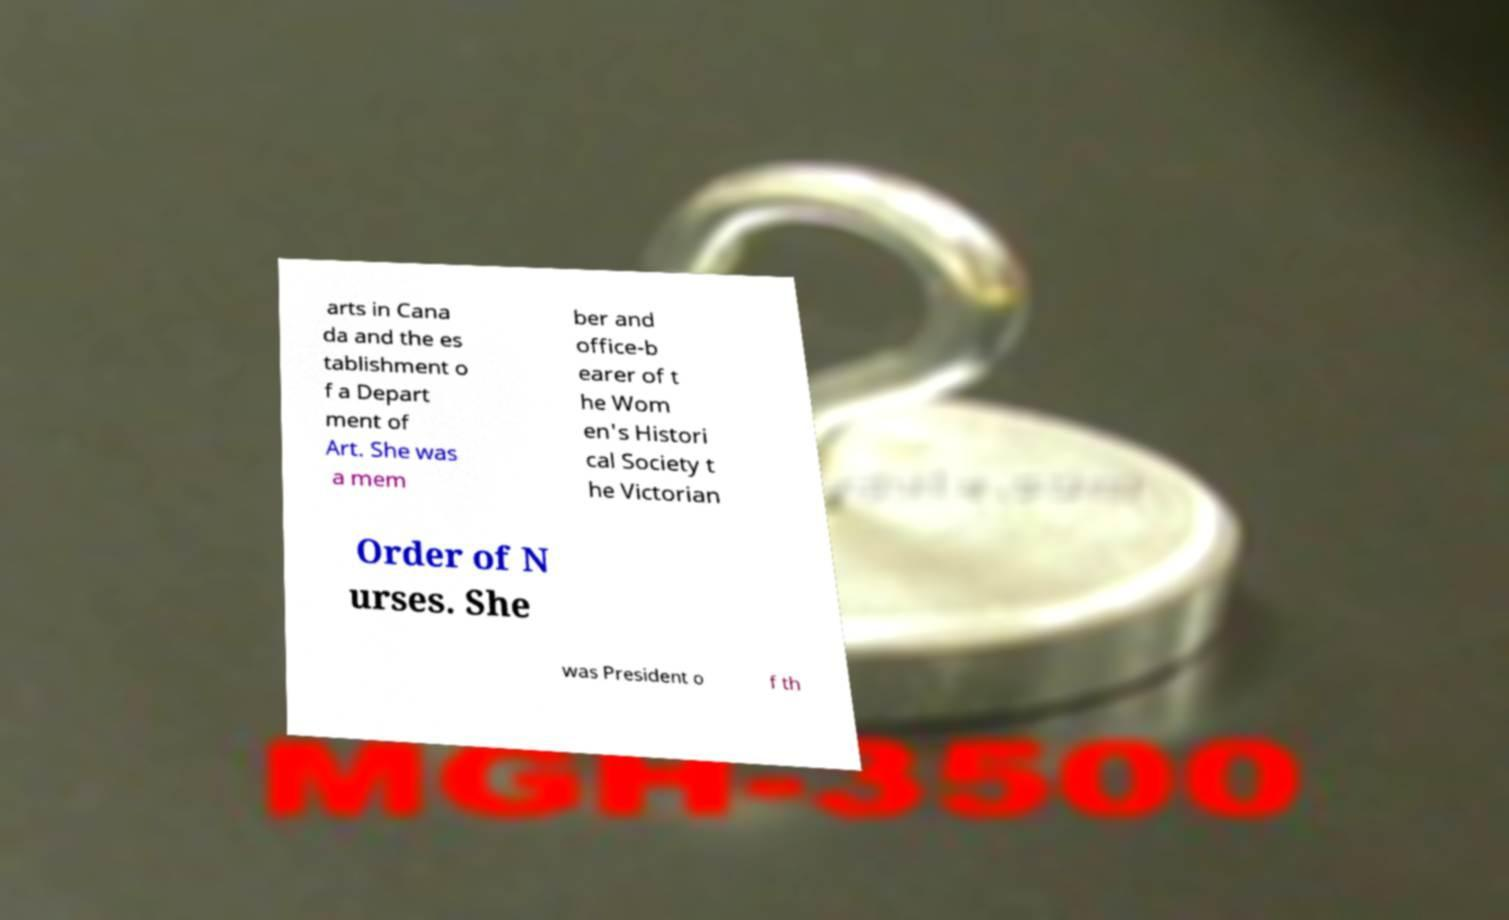Can you read and provide the text displayed in the image?This photo seems to have some interesting text. Can you extract and type it out for me? arts in Cana da and the es tablishment o f a Depart ment of Art. She was a mem ber and office-b earer of t he Wom en's Histori cal Society t he Victorian Order of N urses. She was President o f th 